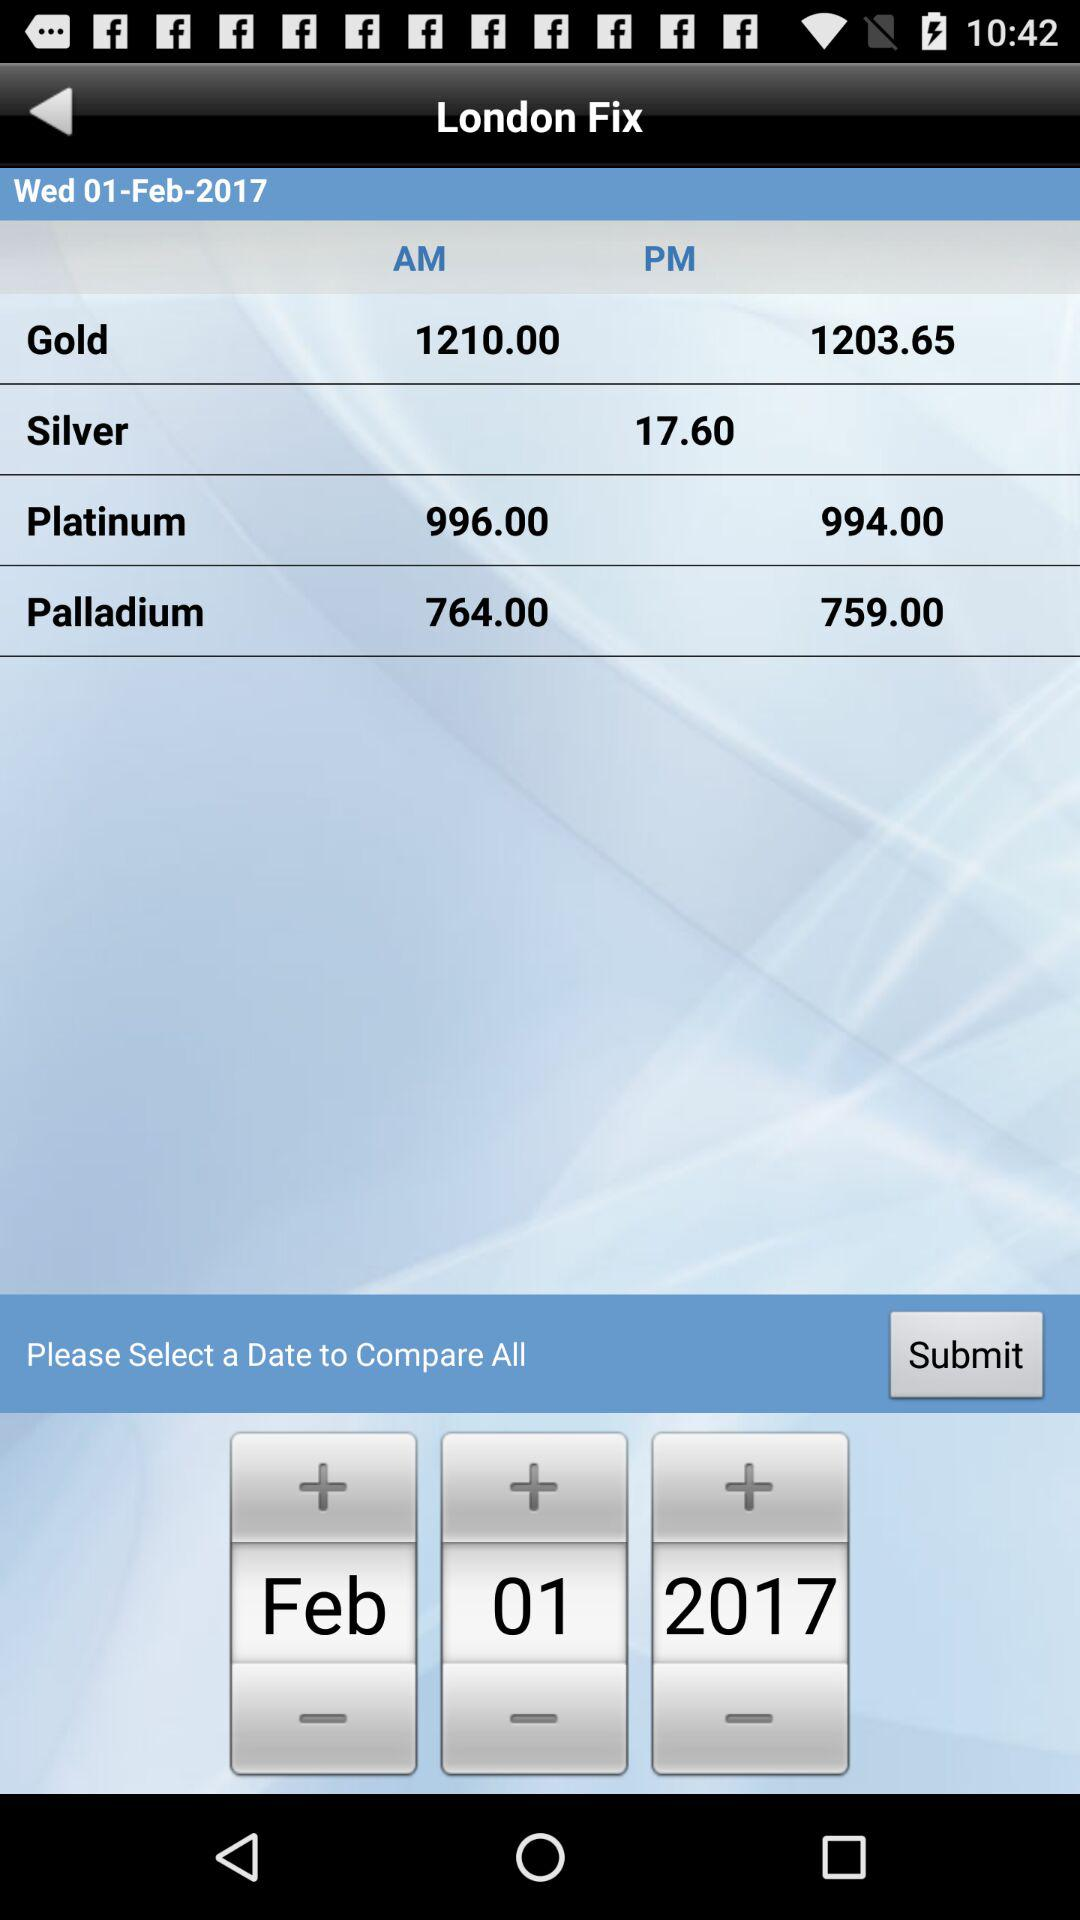Which day falls on February 01, 2017? The day that falls on February 1, 2017 is Wednesday. 